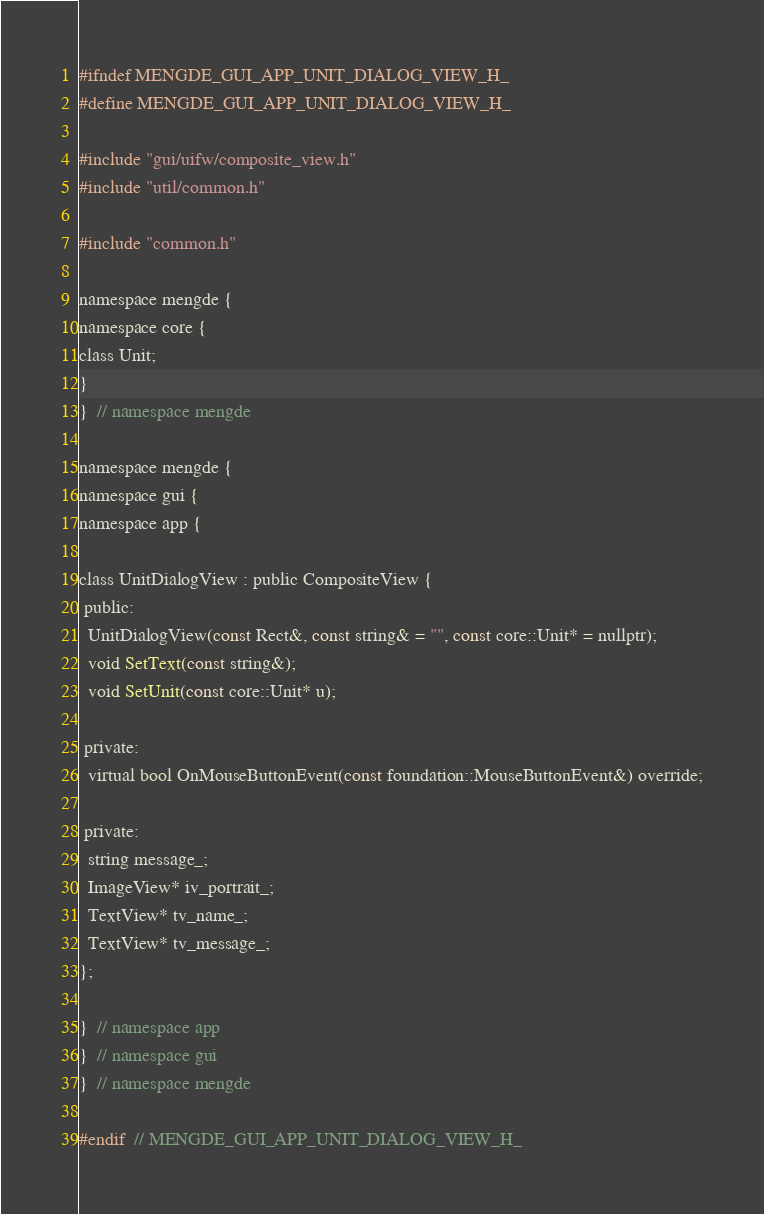Convert code to text. <code><loc_0><loc_0><loc_500><loc_500><_C_>#ifndef MENGDE_GUI_APP_UNIT_DIALOG_VIEW_H_
#define MENGDE_GUI_APP_UNIT_DIALOG_VIEW_H_

#include "gui/uifw/composite_view.h"
#include "util/common.h"

#include "common.h"

namespace mengde {
namespace core {
class Unit;
}
}  // namespace mengde

namespace mengde {
namespace gui {
namespace app {

class UnitDialogView : public CompositeView {
 public:
  UnitDialogView(const Rect&, const string& = "", const core::Unit* = nullptr);
  void SetText(const string&);
  void SetUnit(const core::Unit* u);

 private:
  virtual bool OnMouseButtonEvent(const foundation::MouseButtonEvent&) override;

 private:
  string message_;
  ImageView* iv_portrait_;
  TextView* tv_name_;
  TextView* tv_message_;
};

}  // namespace app
}  // namespace gui
}  // namespace mengde

#endif  // MENGDE_GUI_APP_UNIT_DIALOG_VIEW_H_
</code> 